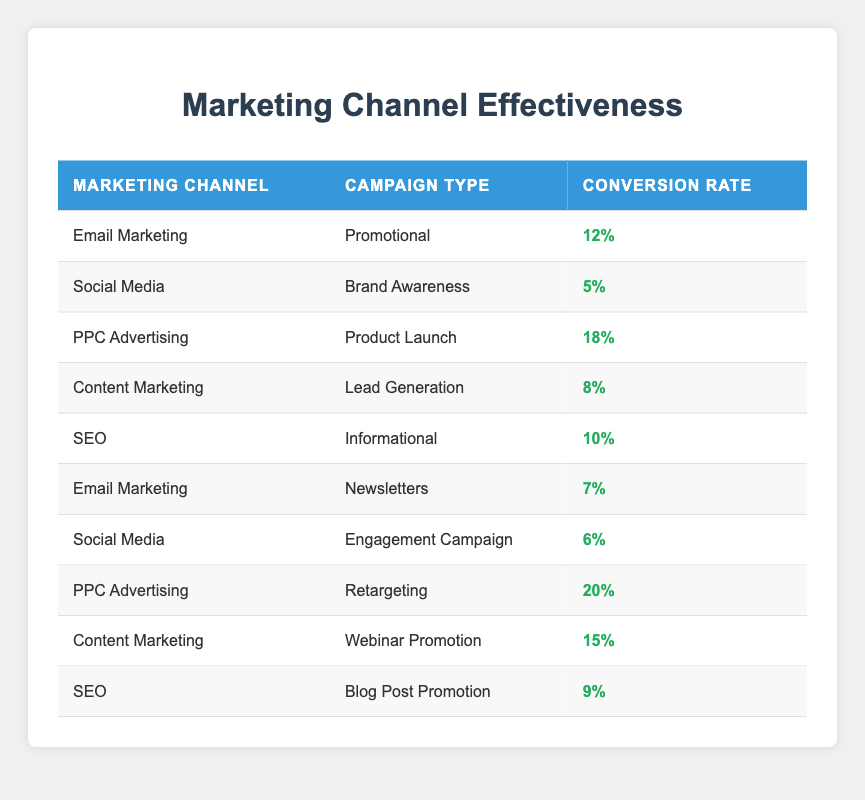What is the highest conversion rate among the marketing channels? The highest conversion rate is found in the "PPC Advertising" under the "Retargeting" campaign type, which shows a conversion rate of 20%.
Answer: 20% Which marketing channel has the lowest conversion rate? The lowest conversion rate is associated with the "Social Media" under the "Brand Awareness" campaign type, which has a conversion rate of 5%.
Answer: 5% What is the average conversion rate for Email Marketing campaigns? The conversion rates for Email Marketing are 12% (Promotional) and 7% (Newsletters). To find the average, we add these values: 12 + 7 = 19, and divide by 2: 19 / 2 = 9.5%.
Answer: 9.5% Did any Campaign Type perform better than 15% conversion rate? Yes, the "PPC Advertising" under "Retargeting" (20%) and "Webinar Promotion" under "Content Marketing" (15%) both perform at or above the 15% threshold.
Answer: Yes What is the total conversion rate for all PPC Advertising campaigns? The PPC Advertising campaigns have conversion rates of 18% (Product Launch) and 20% (Retargeting). Adding these gives 18 + 20 = 38%. The total conversion rate for both campaigns is 38%.
Answer: 38% Which marketing channel and campaign type together achieved a conversion rate of 15%? The "Content Marketing" channel with the "Webinar Promotion" campaign type achieved a conversion rate of 15%.
Answer: Content Marketing - Webinar Promotion Is the conversion rate for SEO Campaign Types generally higher than that of Content Marketing? The SEO campaign types have conversion rates of 10% (Informational) and 9% (Blog Post Promotion). The Content Marketing campaign types have 8% (Lead Generation) and 15% (Webinar Promotion). Combining these shows that the average for SEO is 9.5% while for Content Marketing it is 11.5%, so the Content Marketing is generally higher than SEO.
Answer: No What is the difference in conversion rate between the best and worst performing campaigns? The best performing campaign is from PPC Advertising (20%) and the worst is from Social Media (5%). The difference is calculated by subtracting the lower from the higher: 20 - 5 = 15%.
Answer: 15% 